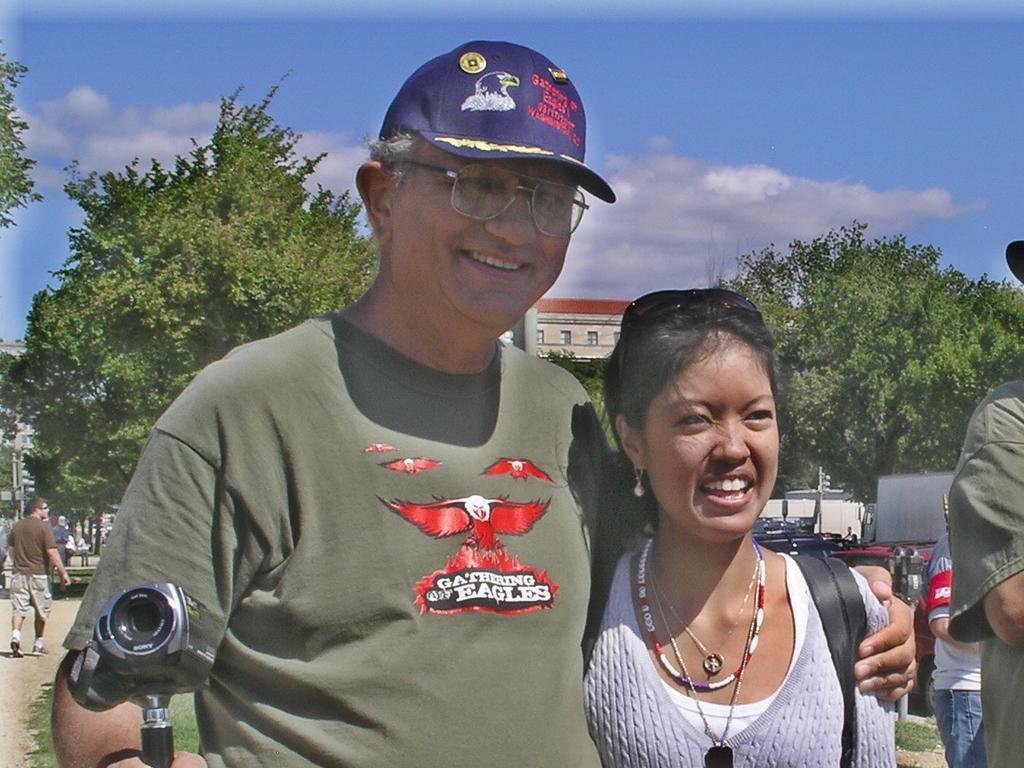Describe this image in one or two sentences. In this picture there is a person holding a woman with one of his hand and a camera in his another hand and there are few other persons and vehicles behind them and there are trees and a building in the background. 